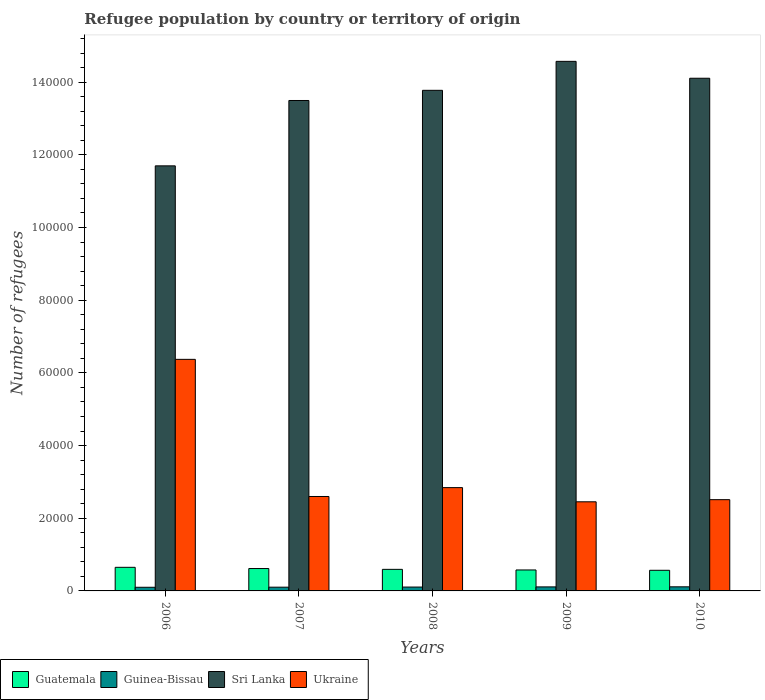How many different coloured bars are there?
Offer a very short reply. 4. Are the number of bars per tick equal to the number of legend labels?
Provide a succinct answer. Yes. How many bars are there on the 1st tick from the right?
Offer a very short reply. 4. What is the number of refugees in Ukraine in 2007?
Your answer should be very brief. 2.60e+04. Across all years, what is the maximum number of refugees in Ukraine?
Give a very brief answer. 6.37e+04. Across all years, what is the minimum number of refugees in Sri Lanka?
Keep it short and to the point. 1.17e+05. What is the total number of refugees in Guinea-Bissau in the graph?
Your response must be concise. 5333. What is the difference between the number of refugees in Sri Lanka in 2006 and that in 2007?
Ensure brevity in your answer.  -1.80e+04. What is the difference between the number of refugees in Guatemala in 2008 and the number of refugees in Ukraine in 2006?
Give a very brief answer. -5.78e+04. What is the average number of refugees in Guatemala per year?
Keep it short and to the point. 6007.6. In the year 2008, what is the difference between the number of refugees in Sri Lanka and number of refugees in Guinea-Bissau?
Your answer should be very brief. 1.37e+05. What is the ratio of the number of refugees in Guatemala in 2009 to that in 2010?
Provide a succinct answer. 1.02. Is the number of refugees in Sri Lanka in 2008 less than that in 2010?
Your answer should be very brief. Yes. What is the difference between the highest and the second highest number of refugees in Sri Lanka?
Your answer should be very brief. 4647. What is the difference between the highest and the lowest number of refugees in Guinea-Bissau?
Provide a short and direct response. 123. What does the 3rd bar from the left in 2008 represents?
Keep it short and to the point. Sri Lanka. What does the 4th bar from the right in 2009 represents?
Give a very brief answer. Guatemala. How many bars are there?
Provide a succinct answer. 20. How many years are there in the graph?
Give a very brief answer. 5. Does the graph contain grids?
Your answer should be very brief. No. Where does the legend appear in the graph?
Offer a terse response. Bottom left. How are the legend labels stacked?
Ensure brevity in your answer.  Horizontal. What is the title of the graph?
Your answer should be very brief. Refugee population by country or territory of origin. What is the label or title of the Y-axis?
Make the answer very short. Number of refugees. What is the Number of refugees in Guatemala in 2006?
Ensure brevity in your answer.  6496. What is the Number of refugees in Guinea-Bissau in 2006?
Ensure brevity in your answer.  1004. What is the Number of refugees in Sri Lanka in 2006?
Give a very brief answer. 1.17e+05. What is the Number of refugees in Ukraine in 2006?
Provide a short and direct response. 6.37e+04. What is the Number of refugees in Guatemala in 2007?
Provide a short and direct response. 6161. What is the Number of refugees in Guinea-Bissau in 2007?
Give a very brief answer. 1028. What is the Number of refugees in Sri Lanka in 2007?
Provide a short and direct response. 1.35e+05. What is the Number of refugees in Ukraine in 2007?
Give a very brief answer. 2.60e+04. What is the Number of refugees in Guatemala in 2008?
Provide a succinct answer. 5934. What is the Number of refugees of Guinea-Bissau in 2008?
Keep it short and to the point. 1065. What is the Number of refugees of Sri Lanka in 2008?
Offer a very short reply. 1.38e+05. What is the Number of refugees in Ukraine in 2008?
Provide a short and direct response. 2.84e+04. What is the Number of refugees of Guatemala in 2009?
Offer a terse response. 5768. What is the Number of refugees in Guinea-Bissau in 2009?
Your answer should be very brief. 1109. What is the Number of refugees of Sri Lanka in 2009?
Provide a succinct answer. 1.46e+05. What is the Number of refugees in Ukraine in 2009?
Offer a terse response. 2.45e+04. What is the Number of refugees in Guatemala in 2010?
Keep it short and to the point. 5679. What is the Number of refugees of Guinea-Bissau in 2010?
Your answer should be very brief. 1127. What is the Number of refugees of Sri Lanka in 2010?
Offer a very short reply. 1.41e+05. What is the Number of refugees in Ukraine in 2010?
Give a very brief answer. 2.51e+04. Across all years, what is the maximum Number of refugees in Guatemala?
Give a very brief answer. 6496. Across all years, what is the maximum Number of refugees of Guinea-Bissau?
Offer a terse response. 1127. Across all years, what is the maximum Number of refugees in Sri Lanka?
Keep it short and to the point. 1.46e+05. Across all years, what is the maximum Number of refugees of Ukraine?
Ensure brevity in your answer.  6.37e+04. Across all years, what is the minimum Number of refugees in Guatemala?
Offer a terse response. 5679. Across all years, what is the minimum Number of refugees in Guinea-Bissau?
Provide a succinct answer. 1004. Across all years, what is the minimum Number of refugees of Sri Lanka?
Provide a short and direct response. 1.17e+05. Across all years, what is the minimum Number of refugees of Ukraine?
Offer a very short reply. 2.45e+04. What is the total Number of refugees in Guatemala in the graph?
Offer a terse response. 3.00e+04. What is the total Number of refugees of Guinea-Bissau in the graph?
Provide a succinct answer. 5333. What is the total Number of refugees in Sri Lanka in the graph?
Provide a succinct answer. 6.76e+05. What is the total Number of refugees in Ukraine in the graph?
Your answer should be compact. 1.68e+05. What is the difference between the Number of refugees in Guatemala in 2006 and that in 2007?
Your answer should be very brief. 335. What is the difference between the Number of refugees in Guinea-Bissau in 2006 and that in 2007?
Your answer should be compact. -24. What is the difference between the Number of refugees in Sri Lanka in 2006 and that in 2007?
Give a very brief answer. -1.80e+04. What is the difference between the Number of refugees of Ukraine in 2006 and that in 2007?
Make the answer very short. 3.77e+04. What is the difference between the Number of refugees of Guatemala in 2006 and that in 2008?
Ensure brevity in your answer.  562. What is the difference between the Number of refugees of Guinea-Bissau in 2006 and that in 2008?
Your answer should be very brief. -61. What is the difference between the Number of refugees in Sri Lanka in 2006 and that in 2008?
Offer a very short reply. -2.08e+04. What is the difference between the Number of refugees of Ukraine in 2006 and that in 2008?
Your response must be concise. 3.53e+04. What is the difference between the Number of refugees in Guatemala in 2006 and that in 2009?
Provide a succinct answer. 728. What is the difference between the Number of refugees in Guinea-Bissau in 2006 and that in 2009?
Your answer should be compact. -105. What is the difference between the Number of refugees of Sri Lanka in 2006 and that in 2009?
Your answer should be very brief. -2.88e+04. What is the difference between the Number of refugees of Ukraine in 2006 and that in 2009?
Offer a terse response. 3.92e+04. What is the difference between the Number of refugees in Guatemala in 2006 and that in 2010?
Offer a very short reply. 817. What is the difference between the Number of refugees of Guinea-Bissau in 2006 and that in 2010?
Make the answer very short. -123. What is the difference between the Number of refugees in Sri Lanka in 2006 and that in 2010?
Make the answer very short. -2.41e+04. What is the difference between the Number of refugees of Ukraine in 2006 and that in 2010?
Your answer should be compact. 3.86e+04. What is the difference between the Number of refugees of Guatemala in 2007 and that in 2008?
Your answer should be compact. 227. What is the difference between the Number of refugees in Guinea-Bissau in 2007 and that in 2008?
Your response must be concise. -37. What is the difference between the Number of refugees in Sri Lanka in 2007 and that in 2008?
Your response must be concise. -2800. What is the difference between the Number of refugees of Ukraine in 2007 and that in 2008?
Provide a succinct answer. -2439. What is the difference between the Number of refugees of Guatemala in 2007 and that in 2009?
Keep it short and to the point. 393. What is the difference between the Number of refugees in Guinea-Bissau in 2007 and that in 2009?
Keep it short and to the point. -81. What is the difference between the Number of refugees of Sri Lanka in 2007 and that in 2009?
Your answer should be very brief. -1.08e+04. What is the difference between the Number of refugees of Ukraine in 2007 and that in 2009?
Ensure brevity in your answer.  1463. What is the difference between the Number of refugees in Guatemala in 2007 and that in 2010?
Your answer should be very brief. 482. What is the difference between the Number of refugees of Guinea-Bissau in 2007 and that in 2010?
Give a very brief answer. -99. What is the difference between the Number of refugees of Sri Lanka in 2007 and that in 2010?
Provide a succinct answer. -6122. What is the difference between the Number of refugees of Ukraine in 2007 and that in 2010?
Your answer should be very brief. 874. What is the difference between the Number of refugees in Guatemala in 2008 and that in 2009?
Provide a short and direct response. 166. What is the difference between the Number of refugees in Guinea-Bissau in 2008 and that in 2009?
Provide a short and direct response. -44. What is the difference between the Number of refugees of Sri Lanka in 2008 and that in 2009?
Provide a succinct answer. -7969. What is the difference between the Number of refugees in Ukraine in 2008 and that in 2009?
Ensure brevity in your answer.  3902. What is the difference between the Number of refugees of Guatemala in 2008 and that in 2010?
Provide a succinct answer. 255. What is the difference between the Number of refugees of Guinea-Bissau in 2008 and that in 2010?
Your answer should be very brief. -62. What is the difference between the Number of refugees of Sri Lanka in 2008 and that in 2010?
Ensure brevity in your answer.  -3322. What is the difference between the Number of refugees in Ukraine in 2008 and that in 2010?
Offer a very short reply. 3313. What is the difference between the Number of refugees in Guatemala in 2009 and that in 2010?
Your answer should be very brief. 89. What is the difference between the Number of refugees of Sri Lanka in 2009 and that in 2010?
Your answer should be very brief. 4647. What is the difference between the Number of refugees of Ukraine in 2009 and that in 2010?
Provide a short and direct response. -589. What is the difference between the Number of refugees of Guatemala in 2006 and the Number of refugees of Guinea-Bissau in 2007?
Your response must be concise. 5468. What is the difference between the Number of refugees in Guatemala in 2006 and the Number of refugees in Sri Lanka in 2007?
Give a very brief answer. -1.28e+05. What is the difference between the Number of refugees in Guatemala in 2006 and the Number of refugees in Ukraine in 2007?
Provide a short and direct response. -1.95e+04. What is the difference between the Number of refugees in Guinea-Bissau in 2006 and the Number of refugees in Sri Lanka in 2007?
Make the answer very short. -1.34e+05. What is the difference between the Number of refugees of Guinea-Bissau in 2006 and the Number of refugees of Ukraine in 2007?
Your answer should be very brief. -2.50e+04. What is the difference between the Number of refugees of Sri Lanka in 2006 and the Number of refugees of Ukraine in 2007?
Offer a very short reply. 9.10e+04. What is the difference between the Number of refugees of Guatemala in 2006 and the Number of refugees of Guinea-Bissau in 2008?
Ensure brevity in your answer.  5431. What is the difference between the Number of refugees in Guatemala in 2006 and the Number of refugees in Sri Lanka in 2008?
Ensure brevity in your answer.  -1.31e+05. What is the difference between the Number of refugees of Guatemala in 2006 and the Number of refugees of Ukraine in 2008?
Make the answer very short. -2.19e+04. What is the difference between the Number of refugees in Guinea-Bissau in 2006 and the Number of refugees in Sri Lanka in 2008?
Offer a very short reply. -1.37e+05. What is the difference between the Number of refugees of Guinea-Bissau in 2006 and the Number of refugees of Ukraine in 2008?
Give a very brief answer. -2.74e+04. What is the difference between the Number of refugees of Sri Lanka in 2006 and the Number of refugees of Ukraine in 2008?
Provide a short and direct response. 8.85e+04. What is the difference between the Number of refugees in Guatemala in 2006 and the Number of refugees in Guinea-Bissau in 2009?
Provide a short and direct response. 5387. What is the difference between the Number of refugees in Guatemala in 2006 and the Number of refugees in Sri Lanka in 2009?
Your answer should be compact. -1.39e+05. What is the difference between the Number of refugees of Guatemala in 2006 and the Number of refugees of Ukraine in 2009?
Offer a terse response. -1.80e+04. What is the difference between the Number of refugees in Guinea-Bissau in 2006 and the Number of refugees in Sri Lanka in 2009?
Offer a very short reply. -1.45e+05. What is the difference between the Number of refugees in Guinea-Bissau in 2006 and the Number of refugees in Ukraine in 2009?
Give a very brief answer. -2.35e+04. What is the difference between the Number of refugees of Sri Lanka in 2006 and the Number of refugees of Ukraine in 2009?
Your answer should be very brief. 9.24e+04. What is the difference between the Number of refugees of Guatemala in 2006 and the Number of refugees of Guinea-Bissau in 2010?
Give a very brief answer. 5369. What is the difference between the Number of refugees in Guatemala in 2006 and the Number of refugees in Sri Lanka in 2010?
Provide a short and direct response. -1.35e+05. What is the difference between the Number of refugees of Guatemala in 2006 and the Number of refugees of Ukraine in 2010?
Keep it short and to the point. -1.86e+04. What is the difference between the Number of refugees of Guinea-Bissau in 2006 and the Number of refugees of Sri Lanka in 2010?
Your answer should be very brief. -1.40e+05. What is the difference between the Number of refugees in Guinea-Bissau in 2006 and the Number of refugees in Ukraine in 2010?
Give a very brief answer. -2.41e+04. What is the difference between the Number of refugees of Sri Lanka in 2006 and the Number of refugees of Ukraine in 2010?
Your answer should be very brief. 9.19e+04. What is the difference between the Number of refugees of Guatemala in 2007 and the Number of refugees of Guinea-Bissau in 2008?
Your response must be concise. 5096. What is the difference between the Number of refugees in Guatemala in 2007 and the Number of refugees in Sri Lanka in 2008?
Make the answer very short. -1.32e+05. What is the difference between the Number of refugees in Guatemala in 2007 and the Number of refugees in Ukraine in 2008?
Make the answer very short. -2.23e+04. What is the difference between the Number of refugees of Guinea-Bissau in 2007 and the Number of refugees of Sri Lanka in 2008?
Your answer should be compact. -1.37e+05. What is the difference between the Number of refugees in Guinea-Bissau in 2007 and the Number of refugees in Ukraine in 2008?
Make the answer very short. -2.74e+04. What is the difference between the Number of refugees in Sri Lanka in 2007 and the Number of refugees in Ukraine in 2008?
Your response must be concise. 1.07e+05. What is the difference between the Number of refugees in Guatemala in 2007 and the Number of refugees in Guinea-Bissau in 2009?
Provide a succinct answer. 5052. What is the difference between the Number of refugees of Guatemala in 2007 and the Number of refugees of Sri Lanka in 2009?
Offer a very short reply. -1.40e+05. What is the difference between the Number of refugees of Guatemala in 2007 and the Number of refugees of Ukraine in 2009?
Make the answer very short. -1.84e+04. What is the difference between the Number of refugees in Guinea-Bissau in 2007 and the Number of refugees in Sri Lanka in 2009?
Offer a very short reply. -1.45e+05. What is the difference between the Number of refugees in Guinea-Bissau in 2007 and the Number of refugees in Ukraine in 2009?
Provide a succinct answer. -2.35e+04. What is the difference between the Number of refugees of Sri Lanka in 2007 and the Number of refugees of Ukraine in 2009?
Provide a short and direct response. 1.10e+05. What is the difference between the Number of refugees in Guatemala in 2007 and the Number of refugees in Guinea-Bissau in 2010?
Offer a terse response. 5034. What is the difference between the Number of refugees of Guatemala in 2007 and the Number of refugees of Sri Lanka in 2010?
Offer a very short reply. -1.35e+05. What is the difference between the Number of refugees of Guatemala in 2007 and the Number of refugees of Ukraine in 2010?
Ensure brevity in your answer.  -1.90e+04. What is the difference between the Number of refugees in Guinea-Bissau in 2007 and the Number of refugees in Sri Lanka in 2010?
Provide a succinct answer. -1.40e+05. What is the difference between the Number of refugees in Guinea-Bissau in 2007 and the Number of refugees in Ukraine in 2010?
Your answer should be compact. -2.41e+04. What is the difference between the Number of refugees in Sri Lanka in 2007 and the Number of refugees in Ukraine in 2010?
Provide a succinct answer. 1.10e+05. What is the difference between the Number of refugees of Guatemala in 2008 and the Number of refugees of Guinea-Bissau in 2009?
Your answer should be compact. 4825. What is the difference between the Number of refugees of Guatemala in 2008 and the Number of refugees of Sri Lanka in 2009?
Give a very brief answer. -1.40e+05. What is the difference between the Number of refugees of Guatemala in 2008 and the Number of refugees of Ukraine in 2009?
Offer a terse response. -1.86e+04. What is the difference between the Number of refugees of Guinea-Bissau in 2008 and the Number of refugees of Sri Lanka in 2009?
Ensure brevity in your answer.  -1.45e+05. What is the difference between the Number of refugees in Guinea-Bissau in 2008 and the Number of refugees in Ukraine in 2009?
Offer a very short reply. -2.35e+04. What is the difference between the Number of refugees in Sri Lanka in 2008 and the Number of refugees in Ukraine in 2009?
Your answer should be compact. 1.13e+05. What is the difference between the Number of refugees in Guatemala in 2008 and the Number of refugees in Guinea-Bissau in 2010?
Ensure brevity in your answer.  4807. What is the difference between the Number of refugees of Guatemala in 2008 and the Number of refugees of Sri Lanka in 2010?
Make the answer very short. -1.35e+05. What is the difference between the Number of refugees of Guatemala in 2008 and the Number of refugees of Ukraine in 2010?
Keep it short and to the point. -1.92e+04. What is the difference between the Number of refugees in Guinea-Bissau in 2008 and the Number of refugees in Sri Lanka in 2010?
Provide a short and direct response. -1.40e+05. What is the difference between the Number of refugees in Guinea-Bissau in 2008 and the Number of refugees in Ukraine in 2010?
Your response must be concise. -2.40e+04. What is the difference between the Number of refugees in Sri Lanka in 2008 and the Number of refugees in Ukraine in 2010?
Provide a succinct answer. 1.13e+05. What is the difference between the Number of refugees in Guatemala in 2009 and the Number of refugees in Guinea-Bissau in 2010?
Provide a short and direct response. 4641. What is the difference between the Number of refugees in Guatemala in 2009 and the Number of refugees in Sri Lanka in 2010?
Your answer should be very brief. -1.35e+05. What is the difference between the Number of refugees of Guatemala in 2009 and the Number of refugees of Ukraine in 2010?
Offer a terse response. -1.93e+04. What is the difference between the Number of refugees of Guinea-Bissau in 2009 and the Number of refugees of Sri Lanka in 2010?
Your response must be concise. -1.40e+05. What is the difference between the Number of refugees in Guinea-Bissau in 2009 and the Number of refugees in Ukraine in 2010?
Provide a succinct answer. -2.40e+04. What is the difference between the Number of refugees of Sri Lanka in 2009 and the Number of refugees of Ukraine in 2010?
Provide a short and direct response. 1.21e+05. What is the average Number of refugees of Guatemala per year?
Give a very brief answer. 6007.6. What is the average Number of refugees of Guinea-Bissau per year?
Make the answer very short. 1066.6. What is the average Number of refugees of Sri Lanka per year?
Make the answer very short. 1.35e+05. What is the average Number of refugees in Ukraine per year?
Keep it short and to the point. 3.36e+04. In the year 2006, what is the difference between the Number of refugees in Guatemala and Number of refugees in Guinea-Bissau?
Make the answer very short. 5492. In the year 2006, what is the difference between the Number of refugees in Guatemala and Number of refugees in Sri Lanka?
Provide a succinct answer. -1.10e+05. In the year 2006, what is the difference between the Number of refugees in Guatemala and Number of refugees in Ukraine?
Give a very brief answer. -5.72e+04. In the year 2006, what is the difference between the Number of refugees in Guinea-Bissau and Number of refugees in Sri Lanka?
Give a very brief answer. -1.16e+05. In the year 2006, what is the difference between the Number of refugees of Guinea-Bissau and Number of refugees of Ukraine?
Provide a short and direct response. -6.27e+04. In the year 2006, what is the difference between the Number of refugees in Sri Lanka and Number of refugees in Ukraine?
Offer a very short reply. 5.32e+04. In the year 2007, what is the difference between the Number of refugees in Guatemala and Number of refugees in Guinea-Bissau?
Your answer should be very brief. 5133. In the year 2007, what is the difference between the Number of refugees of Guatemala and Number of refugees of Sri Lanka?
Your answer should be very brief. -1.29e+05. In the year 2007, what is the difference between the Number of refugees of Guatemala and Number of refugees of Ukraine?
Ensure brevity in your answer.  -1.98e+04. In the year 2007, what is the difference between the Number of refugees of Guinea-Bissau and Number of refugees of Sri Lanka?
Provide a short and direct response. -1.34e+05. In the year 2007, what is the difference between the Number of refugees of Guinea-Bissau and Number of refugees of Ukraine?
Your response must be concise. -2.50e+04. In the year 2007, what is the difference between the Number of refugees of Sri Lanka and Number of refugees of Ukraine?
Offer a very short reply. 1.09e+05. In the year 2008, what is the difference between the Number of refugees in Guatemala and Number of refugees in Guinea-Bissau?
Keep it short and to the point. 4869. In the year 2008, what is the difference between the Number of refugees of Guatemala and Number of refugees of Sri Lanka?
Give a very brief answer. -1.32e+05. In the year 2008, what is the difference between the Number of refugees of Guatemala and Number of refugees of Ukraine?
Ensure brevity in your answer.  -2.25e+04. In the year 2008, what is the difference between the Number of refugees in Guinea-Bissau and Number of refugees in Sri Lanka?
Provide a succinct answer. -1.37e+05. In the year 2008, what is the difference between the Number of refugees of Guinea-Bissau and Number of refugees of Ukraine?
Offer a very short reply. -2.74e+04. In the year 2008, what is the difference between the Number of refugees in Sri Lanka and Number of refugees in Ukraine?
Make the answer very short. 1.09e+05. In the year 2009, what is the difference between the Number of refugees in Guatemala and Number of refugees in Guinea-Bissau?
Provide a short and direct response. 4659. In the year 2009, what is the difference between the Number of refugees of Guatemala and Number of refugees of Sri Lanka?
Your answer should be very brief. -1.40e+05. In the year 2009, what is the difference between the Number of refugees of Guatemala and Number of refugees of Ukraine?
Provide a succinct answer. -1.88e+04. In the year 2009, what is the difference between the Number of refugees in Guinea-Bissau and Number of refugees in Sri Lanka?
Your response must be concise. -1.45e+05. In the year 2009, what is the difference between the Number of refugees in Guinea-Bissau and Number of refugees in Ukraine?
Provide a short and direct response. -2.34e+04. In the year 2009, what is the difference between the Number of refugees in Sri Lanka and Number of refugees in Ukraine?
Your response must be concise. 1.21e+05. In the year 2010, what is the difference between the Number of refugees of Guatemala and Number of refugees of Guinea-Bissau?
Ensure brevity in your answer.  4552. In the year 2010, what is the difference between the Number of refugees of Guatemala and Number of refugees of Sri Lanka?
Keep it short and to the point. -1.35e+05. In the year 2010, what is the difference between the Number of refugees in Guatemala and Number of refugees in Ukraine?
Your answer should be compact. -1.94e+04. In the year 2010, what is the difference between the Number of refugees in Guinea-Bissau and Number of refugees in Sri Lanka?
Your answer should be compact. -1.40e+05. In the year 2010, what is the difference between the Number of refugees in Guinea-Bissau and Number of refugees in Ukraine?
Your answer should be compact. -2.40e+04. In the year 2010, what is the difference between the Number of refugees in Sri Lanka and Number of refugees in Ukraine?
Your response must be concise. 1.16e+05. What is the ratio of the Number of refugees of Guatemala in 2006 to that in 2007?
Provide a short and direct response. 1.05. What is the ratio of the Number of refugees of Guinea-Bissau in 2006 to that in 2007?
Your answer should be compact. 0.98. What is the ratio of the Number of refugees in Sri Lanka in 2006 to that in 2007?
Ensure brevity in your answer.  0.87. What is the ratio of the Number of refugees in Ukraine in 2006 to that in 2007?
Offer a very short reply. 2.45. What is the ratio of the Number of refugees in Guatemala in 2006 to that in 2008?
Ensure brevity in your answer.  1.09. What is the ratio of the Number of refugees of Guinea-Bissau in 2006 to that in 2008?
Your answer should be compact. 0.94. What is the ratio of the Number of refugees in Sri Lanka in 2006 to that in 2008?
Keep it short and to the point. 0.85. What is the ratio of the Number of refugees of Ukraine in 2006 to that in 2008?
Offer a very short reply. 2.24. What is the ratio of the Number of refugees of Guatemala in 2006 to that in 2009?
Offer a terse response. 1.13. What is the ratio of the Number of refugees of Guinea-Bissau in 2006 to that in 2009?
Give a very brief answer. 0.91. What is the ratio of the Number of refugees of Sri Lanka in 2006 to that in 2009?
Keep it short and to the point. 0.8. What is the ratio of the Number of refugees of Ukraine in 2006 to that in 2009?
Offer a very short reply. 2.6. What is the ratio of the Number of refugees in Guatemala in 2006 to that in 2010?
Ensure brevity in your answer.  1.14. What is the ratio of the Number of refugees of Guinea-Bissau in 2006 to that in 2010?
Make the answer very short. 0.89. What is the ratio of the Number of refugees of Sri Lanka in 2006 to that in 2010?
Your response must be concise. 0.83. What is the ratio of the Number of refugees of Ukraine in 2006 to that in 2010?
Offer a terse response. 2.54. What is the ratio of the Number of refugees in Guatemala in 2007 to that in 2008?
Provide a short and direct response. 1.04. What is the ratio of the Number of refugees in Guinea-Bissau in 2007 to that in 2008?
Your response must be concise. 0.97. What is the ratio of the Number of refugees of Sri Lanka in 2007 to that in 2008?
Make the answer very short. 0.98. What is the ratio of the Number of refugees of Ukraine in 2007 to that in 2008?
Keep it short and to the point. 0.91. What is the ratio of the Number of refugees in Guatemala in 2007 to that in 2009?
Your answer should be very brief. 1.07. What is the ratio of the Number of refugees of Guinea-Bissau in 2007 to that in 2009?
Your response must be concise. 0.93. What is the ratio of the Number of refugees of Sri Lanka in 2007 to that in 2009?
Keep it short and to the point. 0.93. What is the ratio of the Number of refugees in Ukraine in 2007 to that in 2009?
Your answer should be very brief. 1.06. What is the ratio of the Number of refugees in Guatemala in 2007 to that in 2010?
Your answer should be compact. 1.08. What is the ratio of the Number of refugees of Guinea-Bissau in 2007 to that in 2010?
Your answer should be very brief. 0.91. What is the ratio of the Number of refugees of Sri Lanka in 2007 to that in 2010?
Offer a terse response. 0.96. What is the ratio of the Number of refugees of Ukraine in 2007 to that in 2010?
Your answer should be compact. 1.03. What is the ratio of the Number of refugees in Guatemala in 2008 to that in 2009?
Your answer should be very brief. 1.03. What is the ratio of the Number of refugees of Guinea-Bissau in 2008 to that in 2009?
Provide a short and direct response. 0.96. What is the ratio of the Number of refugees of Sri Lanka in 2008 to that in 2009?
Ensure brevity in your answer.  0.95. What is the ratio of the Number of refugees of Ukraine in 2008 to that in 2009?
Your response must be concise. 1.16. What is the ratio of the Number of refugees in Guatemala in 2008 to that in 2010?
Keep it short and to the point. 1.04. What is the ratio of the Number of refugees in Guinea-Bissau in 2008 to that in 2010?
Your answer should be compact. 0.94. What is the ratio of the Number of refugees in Sri Lanka in 2008 to that in 2010?
Make the answer very short. 0.98. What is the ratio of the Number of refugees of Ukraine in 2008 to that in 2010?
Offer a very short reply. 1.13. What is the ratio of the Number of refugees of Guatemala in 2009 to that in 2010?
Make the answer very short. 1.02. What is the ratio of the Number of refugees of Guinea-Bissau in 2009 to that in 2010?
Ensure brevity in your answer.  0.98. What is the ratio of the Number of refugees of Sri Lanka in 2009 to that in 2010?
Your answer should be compact. 1.03. What is the ratio of the Number of refugees in Ukraine in 2009 to that in 2010?
Your answer should be compact. 0.98. What is the difference between the highest and the second highest Number of refugees of Guatemala?
Give a very brief answer. 335. What is the difference between the highest and the second highest Number of refugees of Sri Lanka?
Your response must be concise. 4647. What is the difference between the highest and the second highest Number of refugees in Ukraine?
Keep it short and to the point. 3.53e+04. What is the difference between the highest and the lowest Number of refugees of Guatemala?
Offer a terse response. 817. What is the difference between the highest and the lowest Number of refugees of Guinea-Bissau?
Offer a very short reply. 123. What is the difference between the highest and the lowest Number of refugees of Sri Lanka?
Provide a succinct answer. 2.88e+04. What is the difference between the highest and the lowest Number of refugees in Ukraine?
Your answer should be very brief. 3.92e+04. 